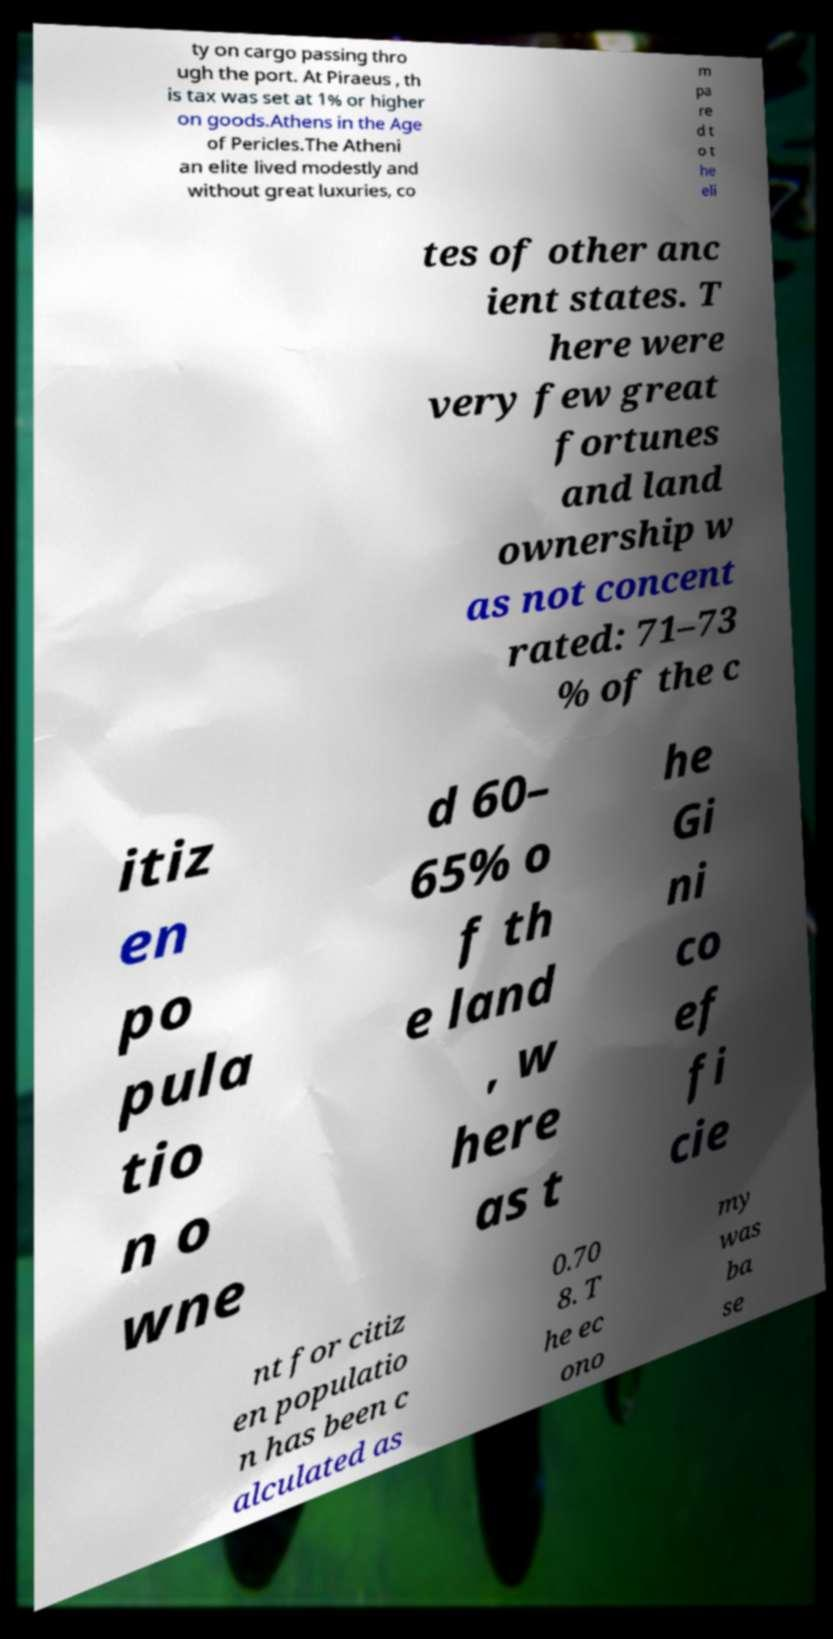Could you assist in decoding the text presented in this image and type it out clearly? ty on cargo passing thro ugh the port. At Piraeus , th is tax was set at 1% or higher on goods.Athens in the Age of Pericles.The Atheni an elite lived modestly and without great luxuries, co m pa re d t o t he eli tes of other anc ient states. T here were very few great fortunes and land ownership w as not concent rated: 71–73 % of the c itiz en po pula tio n o wne d 60– 65% o f th e land , w here as t he Gi ni co ef fi cie nt for citiz en populatio n has been c alculated as 0.70 8. T he ec ono my was ba se 